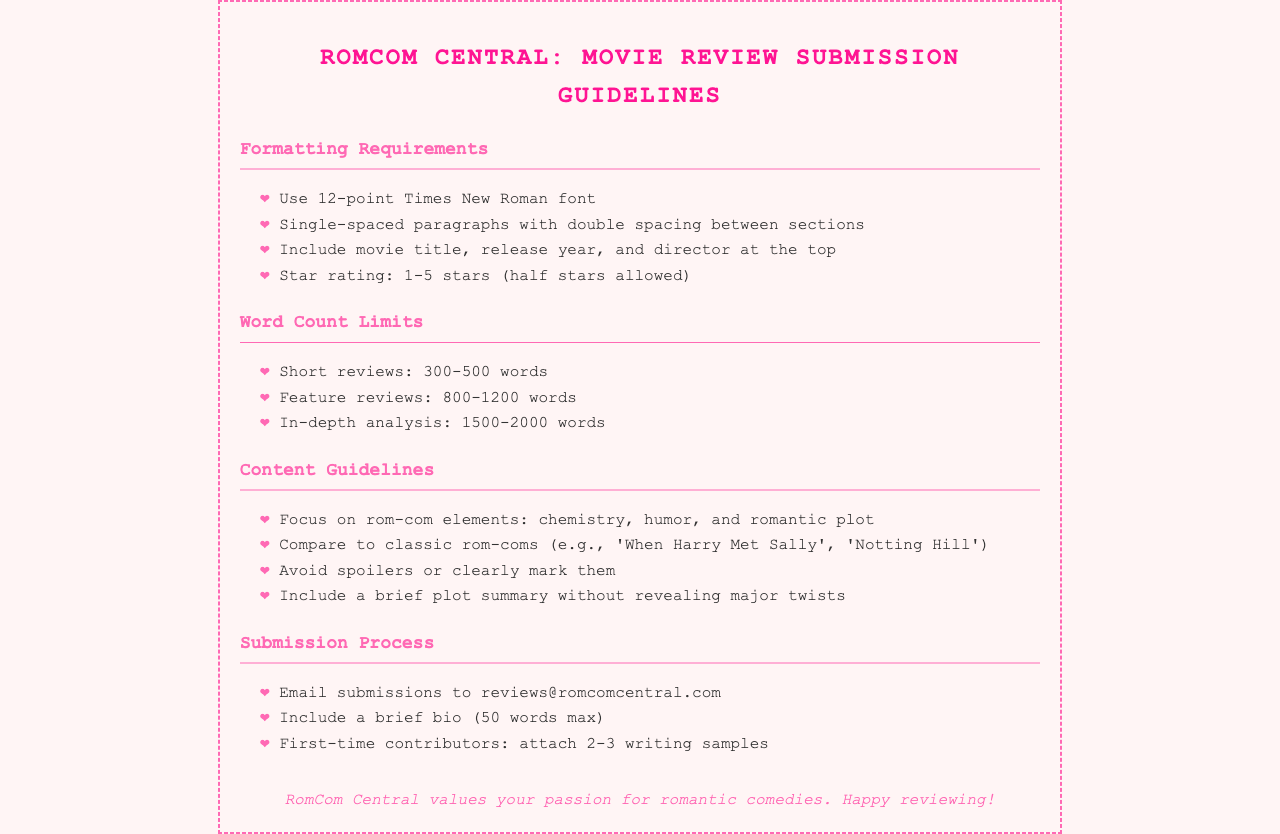what is the required font for submissions? The document states that submissions must use 12-point Times New Roman font.
Answer: 12-point Times New Roman what is the word count limit for in-depth analysis reviews? The document specifies that in-depth analysis reviews should be between 1500-2000 words.
Answer: 1500-2000 words how should the star rating be presented? The document indicates that the star rating should range from 1-5 stars and half stars are allowed.
Answer: 1-5 stars (half stars allowed) where should reviews be submitted? The document provides an email address for submissions, which is reviews@romcomcentral.com.
Answer: reviews@romcomcentral.com what elements should focus in a rom-com review? The document highlights that reviews should focus on chemistry, humor, and romantic plot.
Answer: chemistry, humor, and romantic plot what spacing is required between sections? The document states that there should be double spacing between sections of the review.
Answer: double spacing how long should the author bio be? The document specifies that the author bio should be a maximum of 50 words.
Answer: 50 words max what is the minimum word count for short reviews? The document mentions that short reviews must be at least 300 words.
Answer: 300 words which classic rom-coms should be compared to? The document lists 'When Harry Met Sally' and 'Notting Hill' as examples for comparison.
Answer: 'When Harry Met Sally', 'Notting Hill' what should be included at the top of the review? The document states that the movie title, release year, and director should be included at the top.
Answer: movie title, release year, and director 